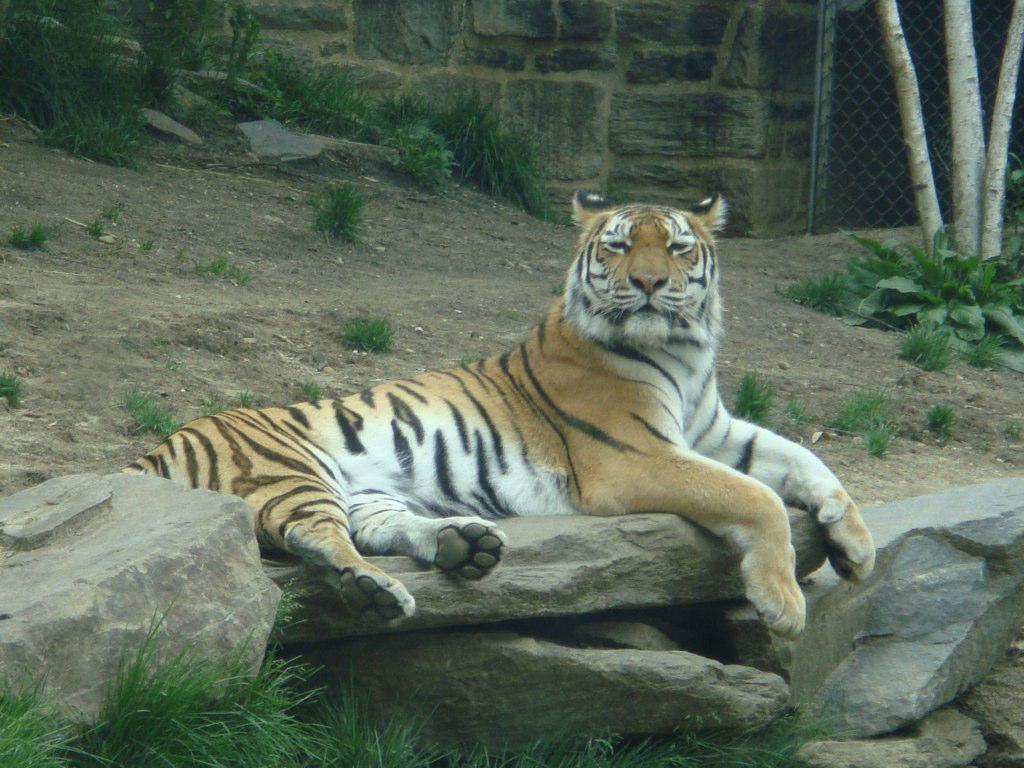In one or two sentences, can you explain what this image depicts? Here in this picture we can see a tiger sitting on the rock stone present over there and we can also see other rock stones present all over there and we can see grass, plants and trees present here and there and in the far we can see a fencing present and beside it we can see a wall present over there. 